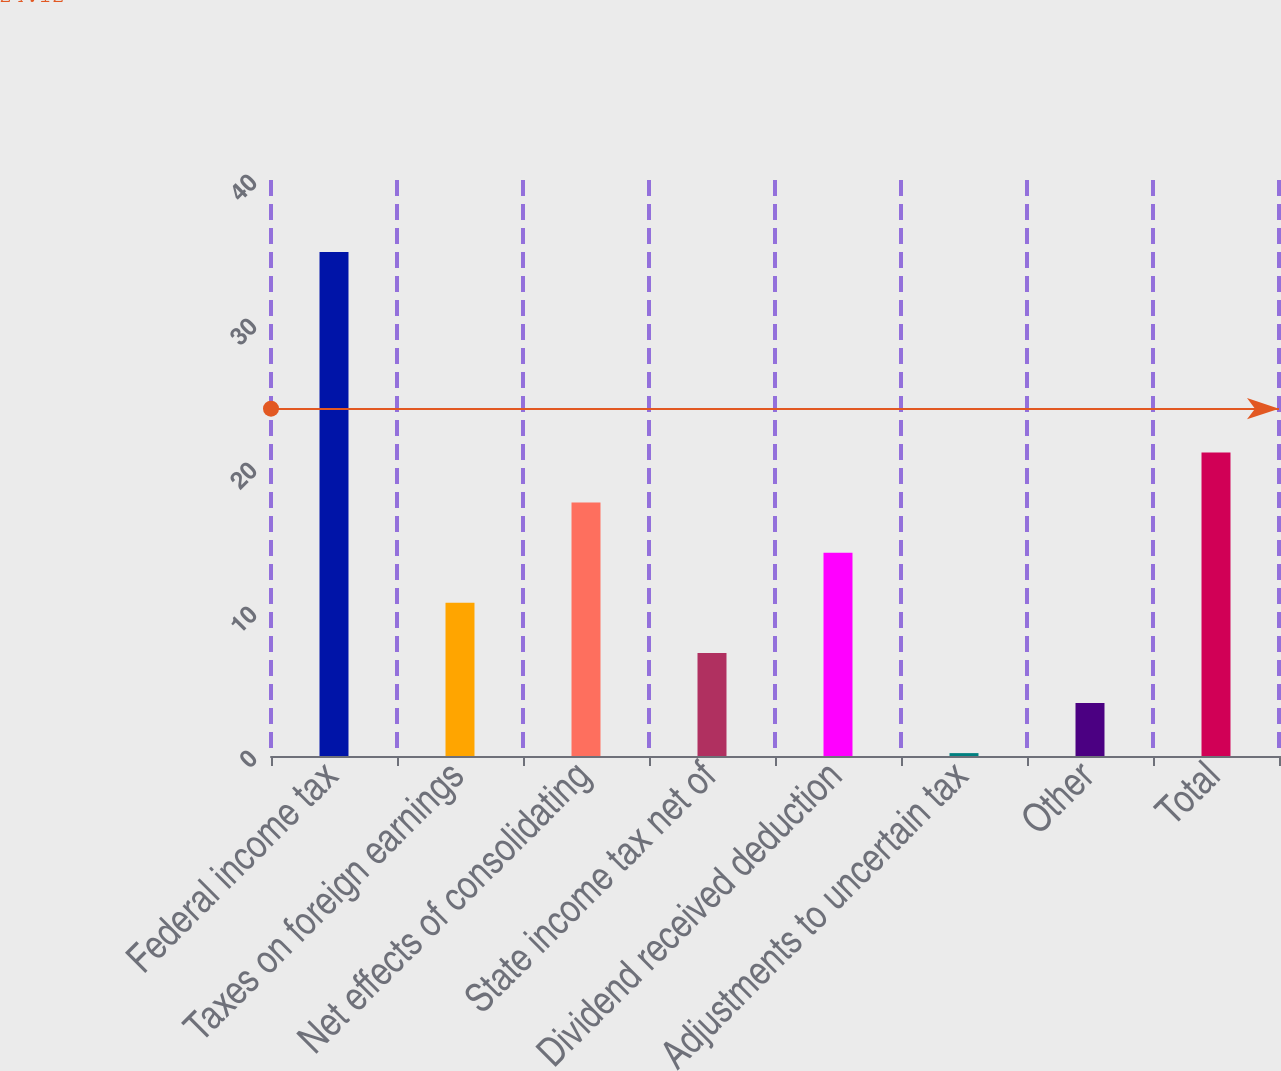Convert chart. <chart><loc_0><loc_0><loc_500><loc_500><bar_chart><fcel>Federal income tax<fcel>Taxes on foreign earnings<fcel>Net effects of consolidating<fcel>State income tax net of<fcel>Dividend received deduction<fcel>Adjustments to uncertain tax<fcel>Other<fcel>Total<nl><fcel>35<fcel>10.64<fcel>17.6<fcel>7.16<fcel>14.12<fcel>0.2<fcel>3.68<fcel>21.08<nl></chart> 